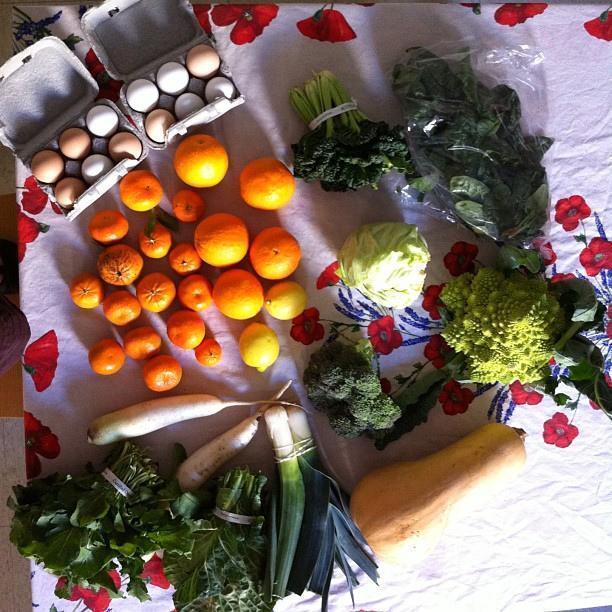Why are the eggs placed in the container?
Indicate the correct choice and explain in the format: 'Answer: answer
Rationale: rationale.'
Options: Protection, to cook, to eat, to dye. Answer: protection.
Rationale: The styrofoam container helps cushion the eggs against breakage in case the package is handled roughly. 